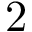Convert formula to latex. <formula><loc_0><loc_0><loc_500><loc_500>2</formula> 